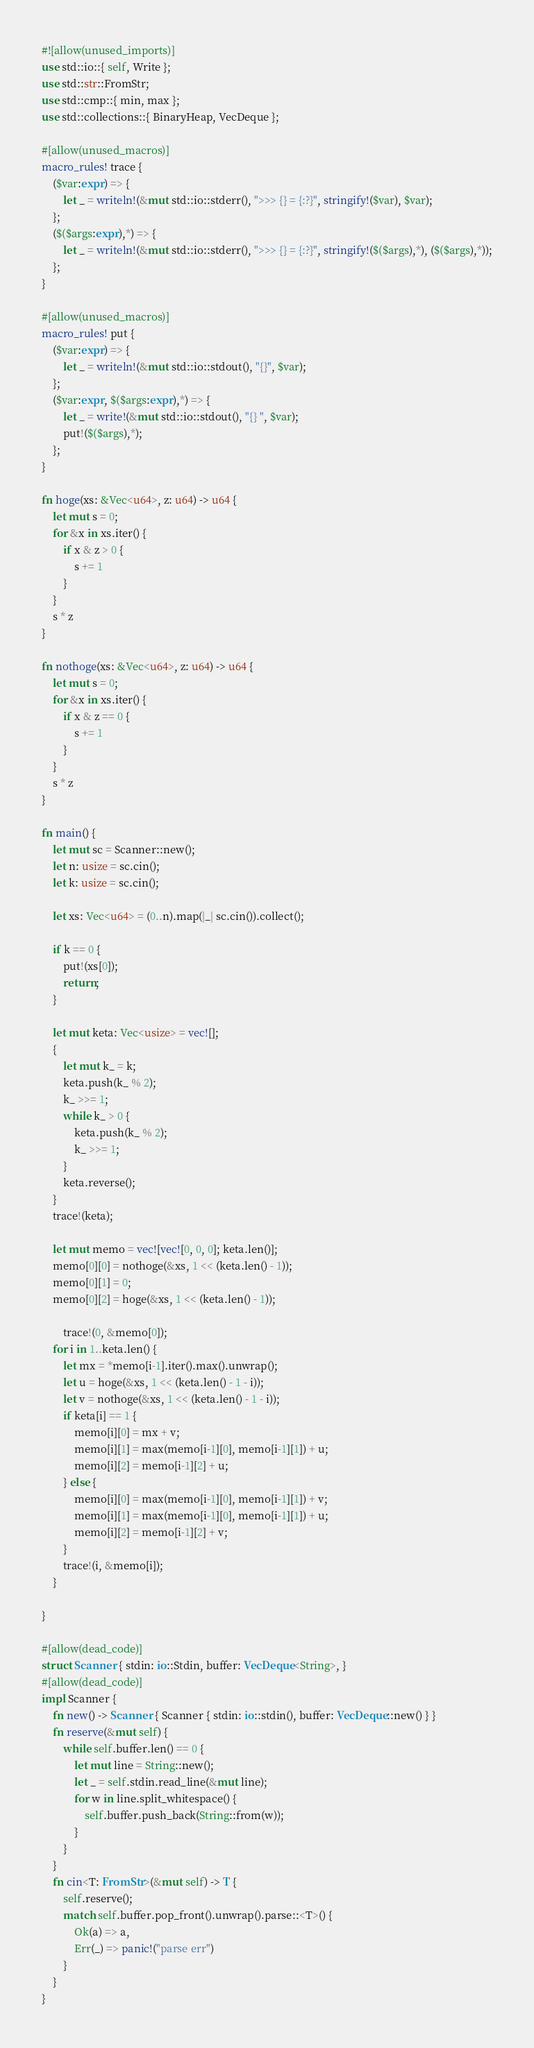<code> <loc_0><loc_0><loc_500><loc_500><_Rust_>#![allow(unused_imports)]
use std::io::{ self, Write };
use std::str::FromStr;
use std::cmp::{ min, max };
use std::collections::{ BinaryHeap, VecDeque };

#[allow(unused_macros)]
macro_rules! trace {
    ($var:expr) => {
        let _ = writeln!(&mut std::io::stderr(), ">>> {} = {:?}", stringify!($var), $var);
    };
    ($($args:expr),*) => {
        let _ = writeln!(&mut std::io::stderr(), ">>> {} = {:?}", stringify!($($args),*), ($($args),*));
    };
}

#[allow(unused_macros)]
macro_rules! put {
    ($var:expr) => {
        let _ = writeln!(&mut std::io::stdout(), "{}", $var);
    };
    ($var:expr, $($args:expr),*) => {
        let _ = write!(&mut std::io::stdout(), "{} ", $var);
        put!($($args),*);
    };
}

fn hoge(xs: &Vec<u64>, z: u64) -> u64 {
    let mut s = 0;
    for &x in xs.iter() {
        if x & z > 0 {
            s += 1
        }
    }
    s * z
}

fn nothoge(xs: &Vec<u64>, z: u64) -> u64 {
    let mut s = 0;
    for &x in xs.iter() {
        if x & z == 0 {
            s += 1
        }
    }
    s * z
}

fn main() {
    let mut sc = Scanner::new();
    let n: usize = sc.cin();
    let k: usize = sc.cin();

    let xs: Vec<u64> = (0..n).map(|_| sc.cin()).collect();

    if k == 0 {
        put!(xs[0]);
        return;
    }

    let mut keta: Vec<usize> = vec![];
    {
        let mut k_ = k;
        keta.push(k_ % 2);
        k_ >>= 1;
        while k_ > 0 {
            keta.push(k_ % 2);
            k_ >>= 1;
        }
        keta.reverse();
    }
    trace!(keta);

    let mut memo = vec![vec![0, 0, 0]; keta.len()];
    memo[0][0] = nothoge(&xs, 1 << (keta.len() - 1));
    memo[0][1] = 0;
    memo[0][2] = hoge(&xs, 1 << (keta.len() - 1));

        trace!(0, &memo[0]);
    for i in 1..keta.len() {
        let mx = *memo[i-1].iter().max().unwrap();
        let u = hoge(&xs, 1 << (keta.len() - 1 - i));
        let v = nothoge(&xs, 1 << (keta.len() - 1 - i));
        if keta[i] == 1 {
            memo[i][0] = mx + v;
            memo[i][1] = max(memo[i-1][0], memo[i-1][1]) + u;
            memo[i][2] = memo[i-1][2] + u;
        } else {
            memo[i][0] = max(memo[i-1][0], memo[i-1][1]) + v;
            memo[i][1] = max(memo[i-1][0], memo[i-1][1]) + u;
            memo[i][2] = memo[i-1][2] + v;
        }
        trace!(i, &memo[i]);
    }

}

#[allow(dead_code)]
struct Scanner { stdin: io::Stdin, buffer: VecDeque<String>, }
#[allow(dead_code)]
impl Scanner {
    fn new() -> Scanner { Scanner { stdin: io::stdin(), buffer: VecDeque::new() } }
    fn reserve(&mut self) {
        while self.buffer.len() == 0 {
            let mut line = String::new();
            let _ = self.stdin.read_line(&mut line);
            for w in line.split_whitespace() {
                self.buffer.push_back(String::from(w));
            }
        }
    }
    fn cin<T: FromStr>(&mut self) -> T {
        self.reserve();
        match self.buffer.pop_front().unwrap().parse::<T>() {
            Ok(a) => a,
            Err(_) => panic!("parse err")
        }
    }
}</code> 